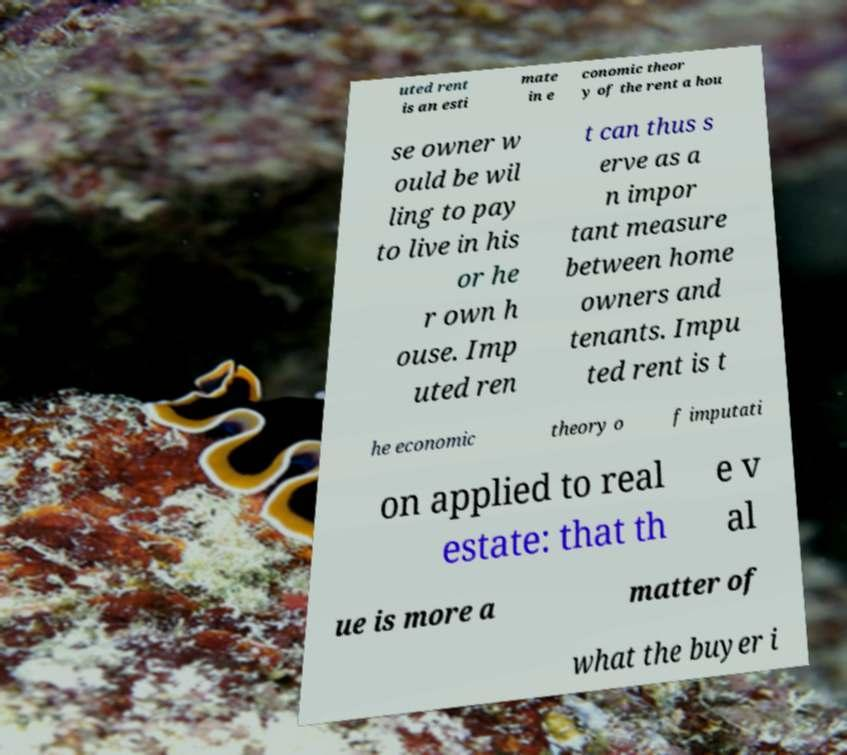Please identify and transcribe the text found in this image. uted rent is an esti mate in e conomic theor y of the rent a hou se owner w ould be wil ling to pay to live in his or he r own h ouse. Imp uted ren t can thus s erve as a n impor tant measure between home owners and tenants. Impu ted rent is t he economic theory o f imputati on applied to real estate: that th e v al ue is more a matter of what the buyer i 